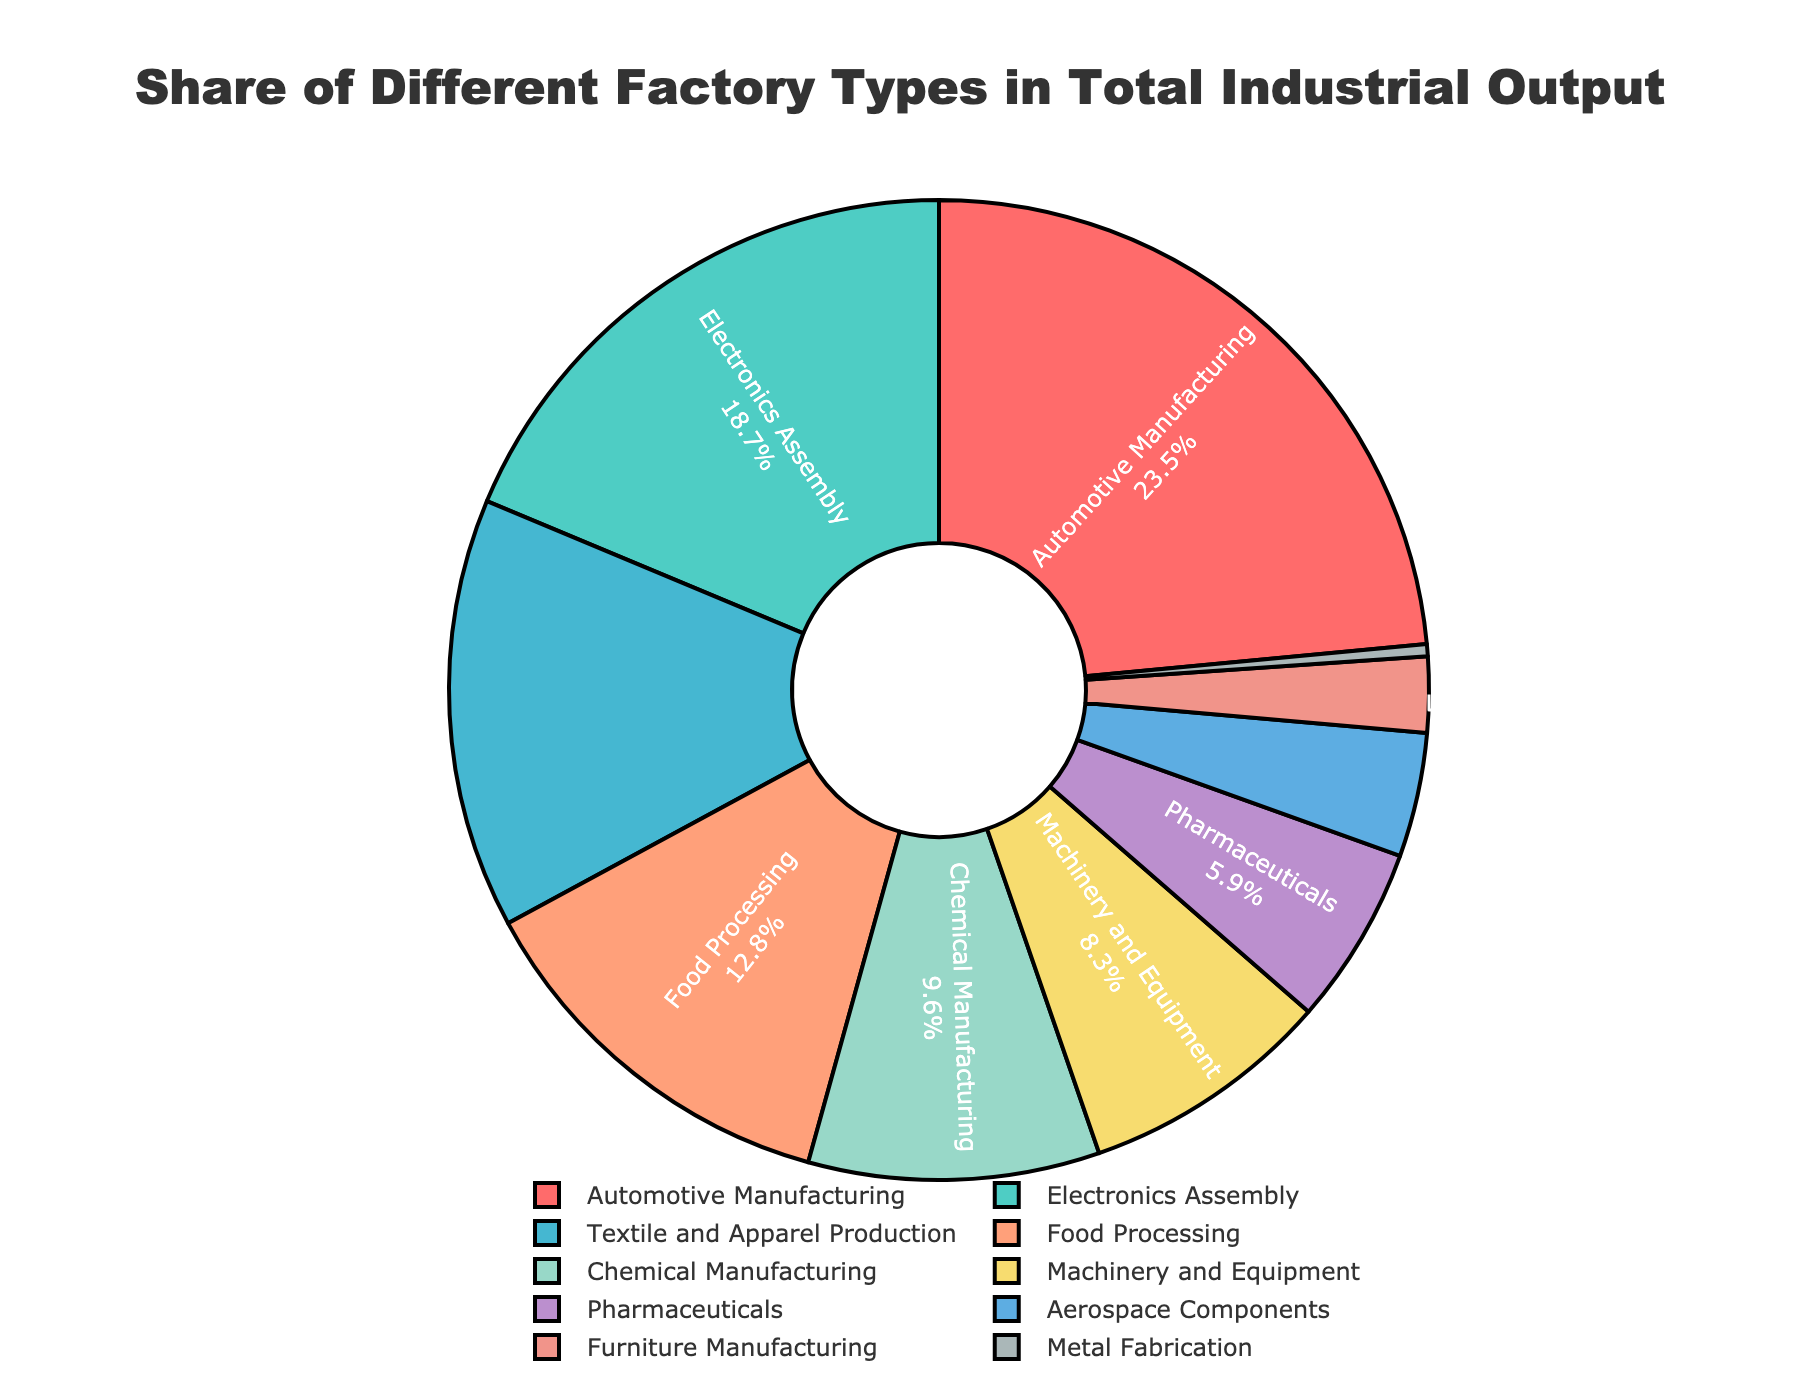Which factory type has the largest share in total industrial output? By examining the pie chart, we can see that the segment labeled "Automotive Manufacturing" is the largest. Therefore, "Automotive Manufacturing" has the largest share in total industrial output.
Answer: Automotive Manufacturing What's the combined share of Textile and Apparel Production and Food Processing? To find the combined share, we sum the shares of the two segments: Textile and Apparel Production which is 14.2% and Food Processing which is 12.8%. Therefore, 14.2 + 12.8 = 27.0%.
Answer: 27.0% What is the difference in the share between Electronics Assembly and Chemical Manufacturing? By referring to the pie chart, we identify that Electronics Assembly holds 18.7% of the share, and Chemical Manufacturing has 9.6%. Subtracting the share of Chemical Manufacturing from Electronics Assembly gives us 18.7 - 9.6 = 9.1%.
Answer: 9.1% Which sector has the smallest share of the total industrial output? By closely examining the pie chart, we see that the smallest segment corresponds to "Metal Fabrication," which is 0.4%.
Answer: Metal Fabrication Is the share of Pharmaceuticals higher than that of Aerospace Components? Comparing the shares based on the pie chart, Pharmaceuticals has a share of 5.9%, while Aerospace Components has a share of 4.1%. Therefore, the share of Pharmaceuticals is higher.
Answer: Yes What color represents the Electronics Assembly sector? By looking at the color-coded pie chart, we see that the Electronics Assembly sector is marked with a greenish-blue color.
Answer: Greenish-blue Which factory types together make up more than half of the total industrial output? Summing up the shares from largest to smallest until we exceed 50%, we have: Automotive Manufacturing (23.5%) and Electronics Assembly (18.7%), which together sum up to 23.5 + 18.7 = 42.2%. Adding Textile and Apparel Production (14.2%) gives us a total of 56.4%. Therefore, these three types together make up more than half of the total output.
Answer: Automotive Manufacturing, Electronics Assembly, Textile and Apparel Production By how much does the share of Automotive Manufacturing exceed that of Machinery and Equipment? The pie chart shows that Automotive Manufacturing has a share of 23.5% and Machinery and Equipment has a share of 8.3%. The difference is 23.5 - 8.3 = 15.2%.
Answer: 15.2% What is the average share of the Furniture Manufacturing and Metal Fabrication sectors? The pie chart indicates that Furniture Manufacturing has a share of 2.5%, and Metal Fabrication has 0.4%. To find the average, we sum these values and divide by 2: (2.5 + 0.4) / 2 = 1.45%.
Answer: 1.45% Which type of factory is represented by a yellow segment, and what is its share? Observing the color-coded segments of the pie chart, the yellow segment corresponds to Chemical Manufacturing. The share for Chemical Manufacturing is 9.6%.
Answer: Chemical Manufacturing, 9.6% 